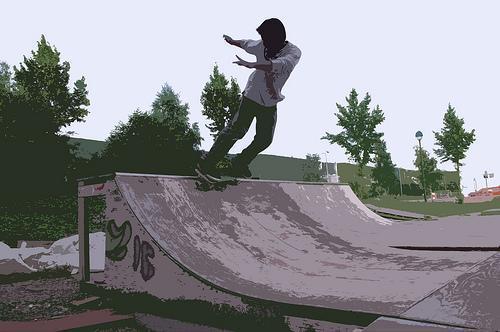How many skateboarders are there?
Give a very brief answer. 1. 